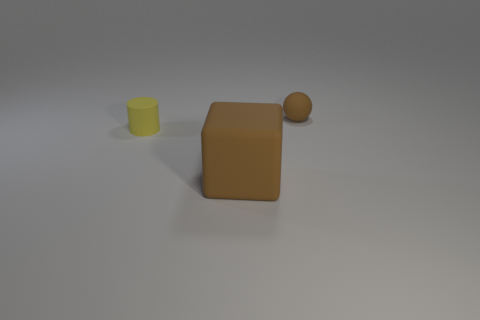Add 1 brown rubber balls. How many objects exist? 4 Add 1 rubber objects. How many rubber objects exist? 4 Subtract 0 purple spheres. How many objects are left? 3 Subtract all blocks. How many objects are left? 2 Subtract all small brown spheres. Subtract all blocks. How many objects are left? 1 Add 1 tiny brown objects. How many tiny brown objects are left? 2 